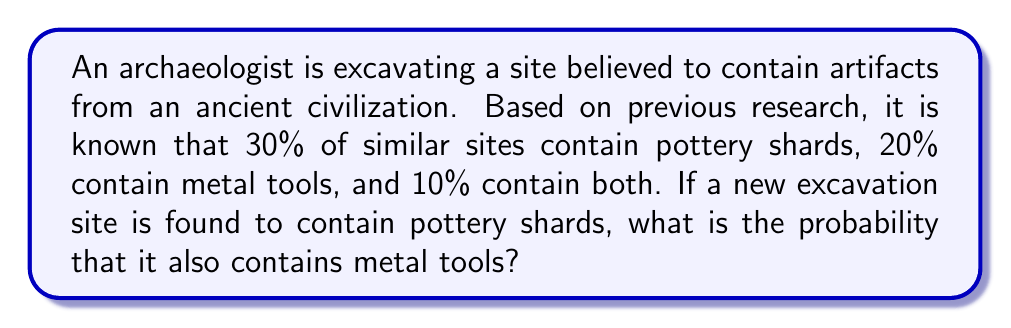Could you help me with this problem? To solve this problem, we'll use Bayesian statistics, specifically the concept of conditional probability. Let's define our events:

$P$: Event of finding pottery shards
$M$: Event of finding metal tools

Given:
$P(P) = 0.30$ (probability of finding pottery shards)
$P(M) = 0.20$ (probability of finding metal tools)
$P(P \cap M) = 0.10$ (probability of finding both pottery shards and metal tools)

We want to find $P(M|P)$, the probability of finding metal tools given that pottery shards have been found.

Using Bayes' theorem:

$$P(M|P) = \frac{P(P|M) \cdot P(M)}{P(P)}$$

We can calculate $P(P|M)$ using the given information:

$$P(P|M) = \frac{P(P \cap M)}{P(M)} = \frac{0.10}{0.20} = 0.50$$

Now we can substitute the values into Bayes' theorem:

$$P(M|P) = \frac{0.50 \cdot 0.20}{0.30} = \frac{0.10}{0.30} = \frac{1}{3}$$

Therefore, the probability of finding metal tools given that pottery shards have been found is $\frac{1}{3}$ or approximately 0.3333 (33.33%).
Answer: $\frac{1}{3}$ or approximately 0.3333 (33.33%) 